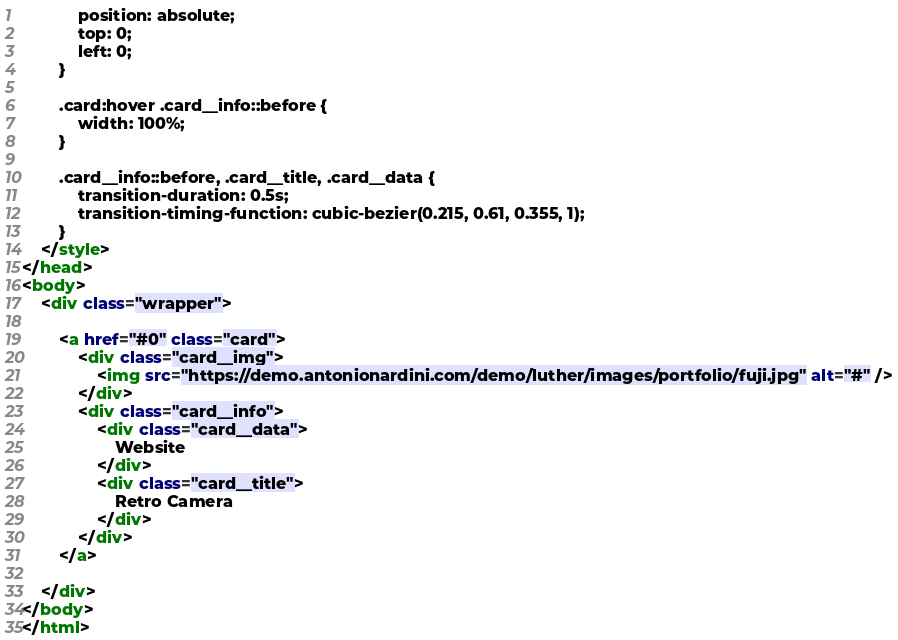<code> <loc_0><loc_0><loc_500><loc_500><_HTML_>            position: absolute;
            top: 0;
            left: 0;
        }

        .card:hover .card__info::before {
            width: 100%;
        }

        .card__info::before, .card__title, .card__data {
            transition-duration: 0.5s;
            transition-timing-function: cubic-bezier(0.215, 0.61, 0.355, 1);
        }
    </style>
</head>
<body>
    <div class="wrapper">

        <a href="#0" class="card">
            <div class="card__img">
                <img src="https://demo.antonionardini.com/demo/luther/images/portfolio/fuji.jpg" alt="#" />
            </div>
            <div class="card__info">
                <div class="card__data">
                    Website
                </div>
                <div class="card__title">
                    Retro Camera
                </div>
            </div>
        </a>

    </div>
</body>
</html></code> 